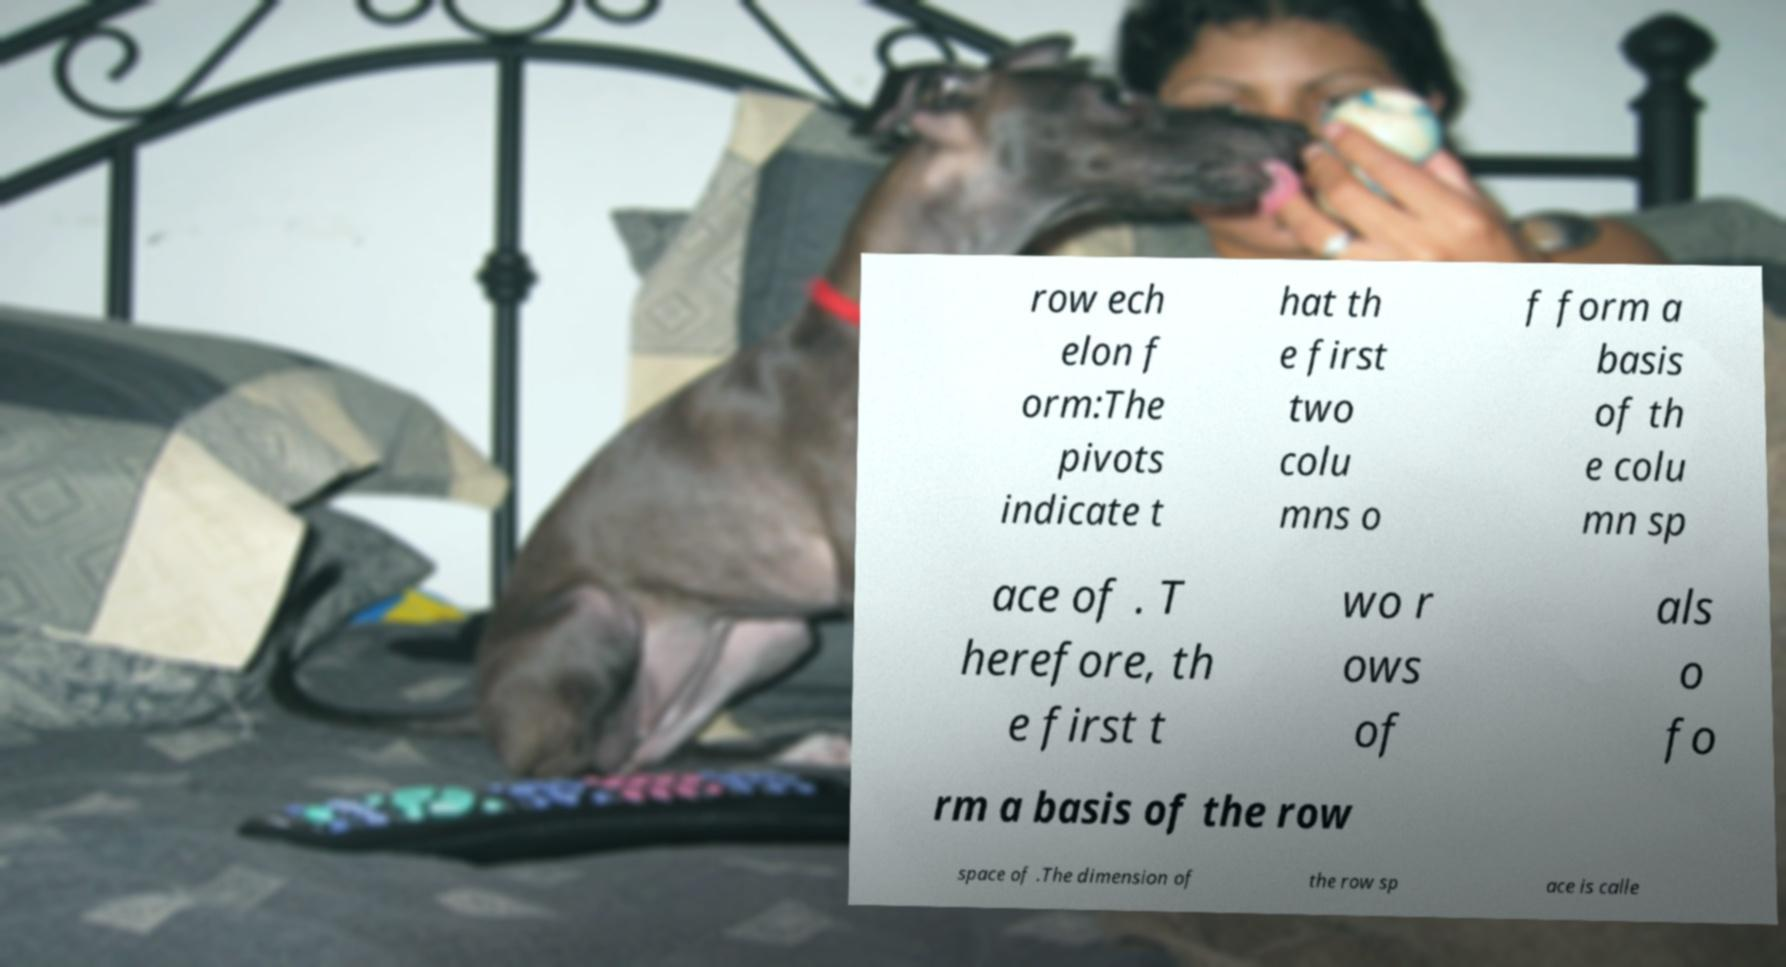There's text embedded in this image that I need extracted. Can you transcribe it verbatim? row ech elon f orm:The pivots indicate t hat th e first two colu mns o f form a basis of th e colu mn sp ace of . T herefore, th e first t wo r ows of als o fo rm a basis of the row space of .The dimension of the row sp ace is calle 